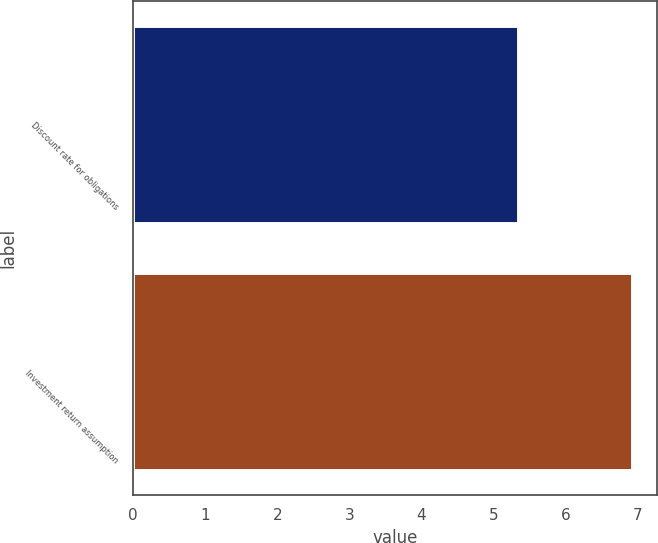Convert chart. <chart><loc_0><loc_0><loc_500><loc_500><bar_chart><fcel>Discount rate for obligations<fcel>Investment return assumption<nl><fcel>5.34<fcel>6.93<nl></chart> 